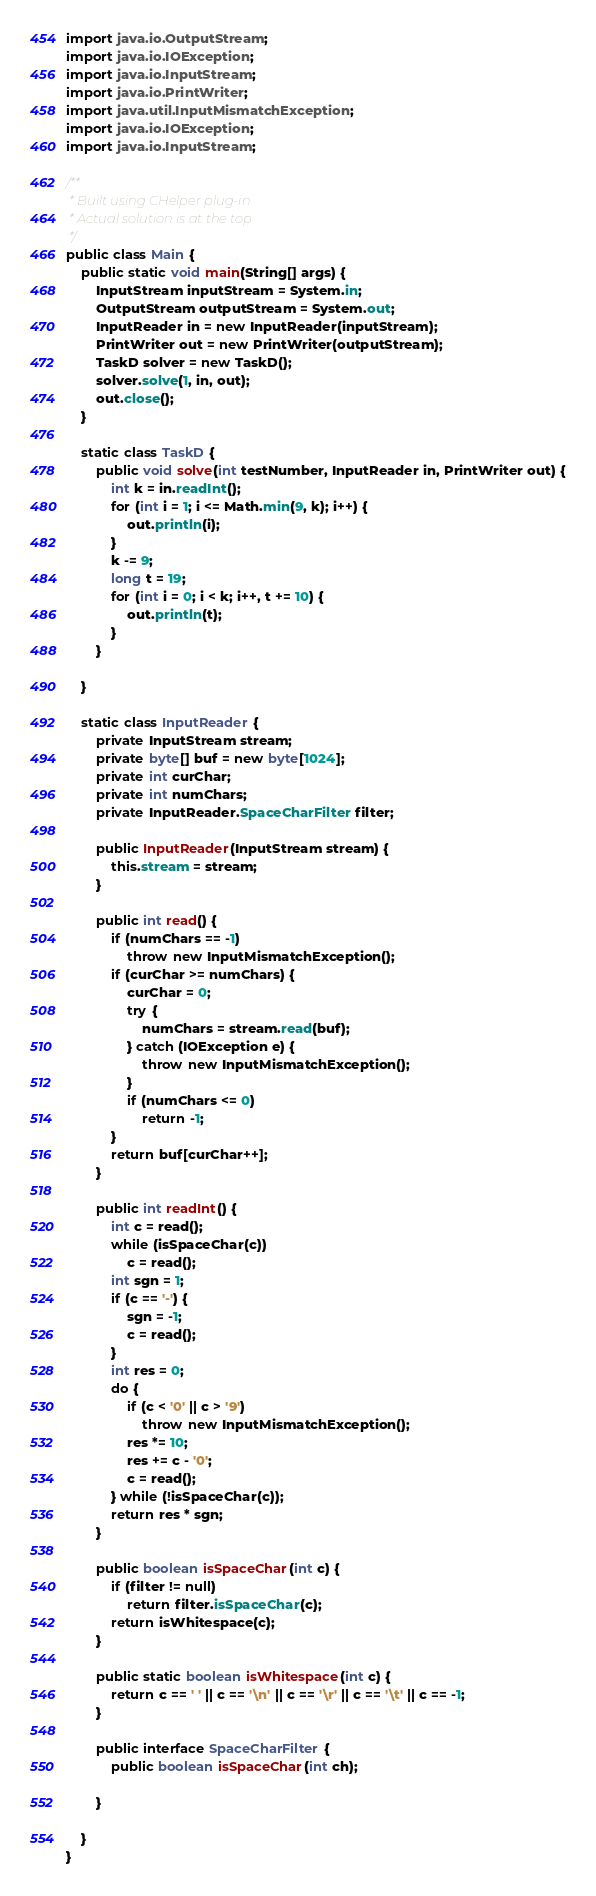<code> <loc_0><loc_0><loc_500><loc_500><_Java_>import java.io.OutputStream;
import java.io.IOException;
import java.io.InputStream;
import java.io.PrintWriter;
import java.util.InputMismatchException;
import java.io.IOException;
import java.io.InputStream;

/**
 * Built using CHelper plug-in
 * Actual solution is at the top
 */
public class Main {
    public static void main(String[] args) {
        InputStream inputStream = System.in;
        OutputStream outputStream = System.out;
        InputReader in = new InputReader(inputStream);
        PrintWriter out = new PrintWriter(outputStream);
        TaskD solver = new TaskD();
        solver.solve(1, in, out);
        out.close();
    }

    static class TaskD {
        public void solve(int testNumber, InputReader in, PrintWriter out) {
            int k = in.readInt();
            for (int i = 1; i <= Math.min(9, k); i++) {
                out.println(i);
            }
            k -= 9;
            long t = 19;
            for (int i = 0; i < k; i++, t += 10) {
                out.println(t);
            }
        }

    }

    static class InputReader {
        private InputStream stream;
        private byte[] buf = new byte[1024];
        private int curChar;
        private int numChars;
        private InputReader.SpaceCharFilter filter;

        public InputReader(InputStream stream) {
            this.stream = stream;
        }

        public int read() {
            if (numChars == -1)
                throw new InputMismatchException();
            if (curChar >= numChars) {
                curChar = 0;
                try {
                    numChars = stream.read(buf);
                } catch (IOException e) {
                    throw new InputMismatchException();
                }
                if (numChars <= 0)
                    return -1;
            }
            return buf[curChar++];
        }

        public int readInt() {
            int c = read();
            while (isSpaceChar(c))
                c = read();
            int sgn = 1;
            if (c == '-') {
                sgn = -1;
                c = read();
            }
            int res = 0;
            do {
                if (c < '0' || c > '9')
                    throw new InputMismatchException();
                res *= 10;
                res += c - '0';
                c = read();
            } while (!isSpaceChar(c));
            return res * sgn;
        }

        public boolean isSpaceChar(int c) {
            if (filter != null)
                return filter.isSpaceChar(c);
            return isWhitespace(c);
        }

        public static boolean isWhitespace(int c) {
            return c == ' ' || c == '\n' || c == '\r' || c == '\t' || c == -1;
        }

        public interface SpaceCharFilter {
            public boolean isSpaceChar(int ch);

        }

    }
}

</code> 